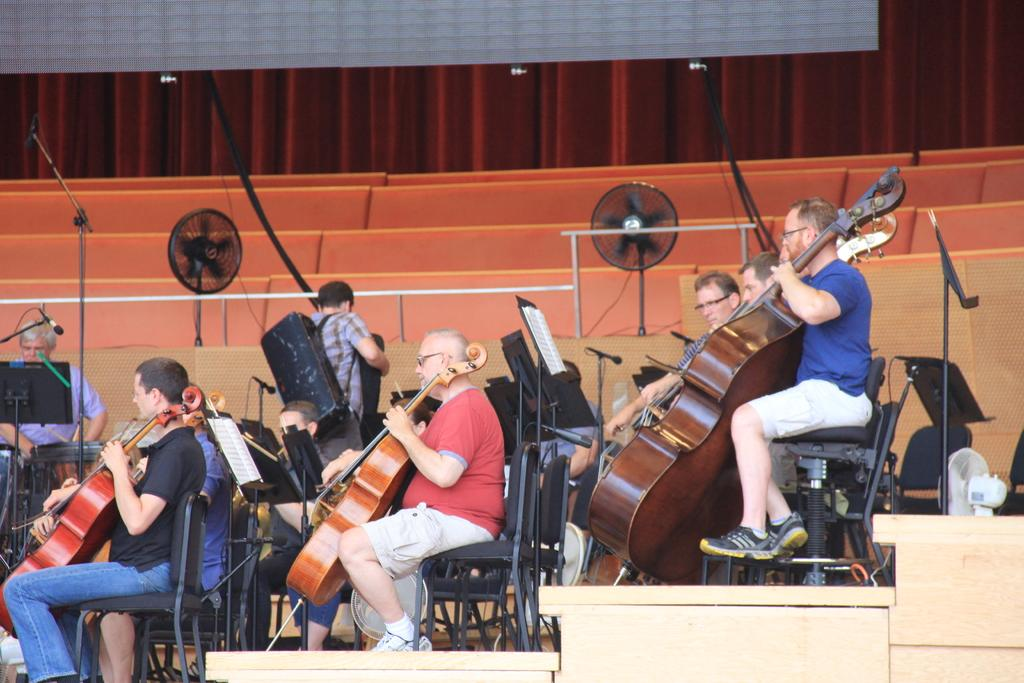What are the people in the image doing? The people in the image are sitting on chairs and playing the guitar. Can you describe the setting in which the people are playing the guitar? The people are sitting on chairs, which suggests they are in a room or an indoor setting. What can be seen in the image besides the people playing the guitar? There is a fan visible in the image. What type of owl can be seen perched on the hill in the image? There is no owl or hill present in the image; it features people sitting on chairs and playing the guitar, along with a fan. 